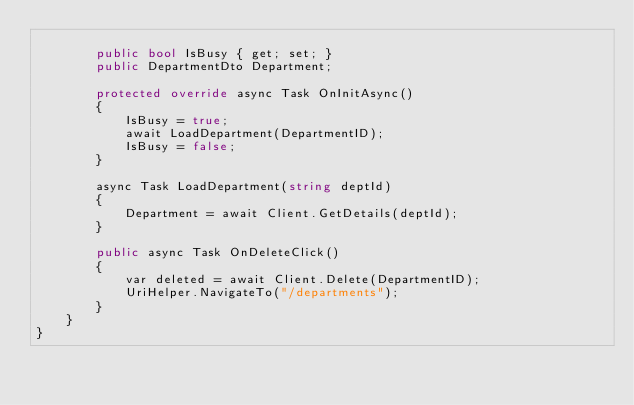Convert code to text. <code><loc_0><loc_0><loc_500><loc_500><_C#_>
        public bool IsBusy { get; set; }
        public DepartmentDto Department;

        protected override async Task OnInitAsync()
        {
            IsBusy = true;
            await LoadDepartment(DepartmentID);
            IsBusy = false;
        }

        async Task LoadDepartment(string deptId)
        {
            Department = await Client.GetDetails(deptId);
        }

        public async Task OnDeleteClick()
        {
            var deleted = await Client.Delete(DepartmentID);
            UriHelper.NavigateTo("/departments");
        }
    }
}</code> 